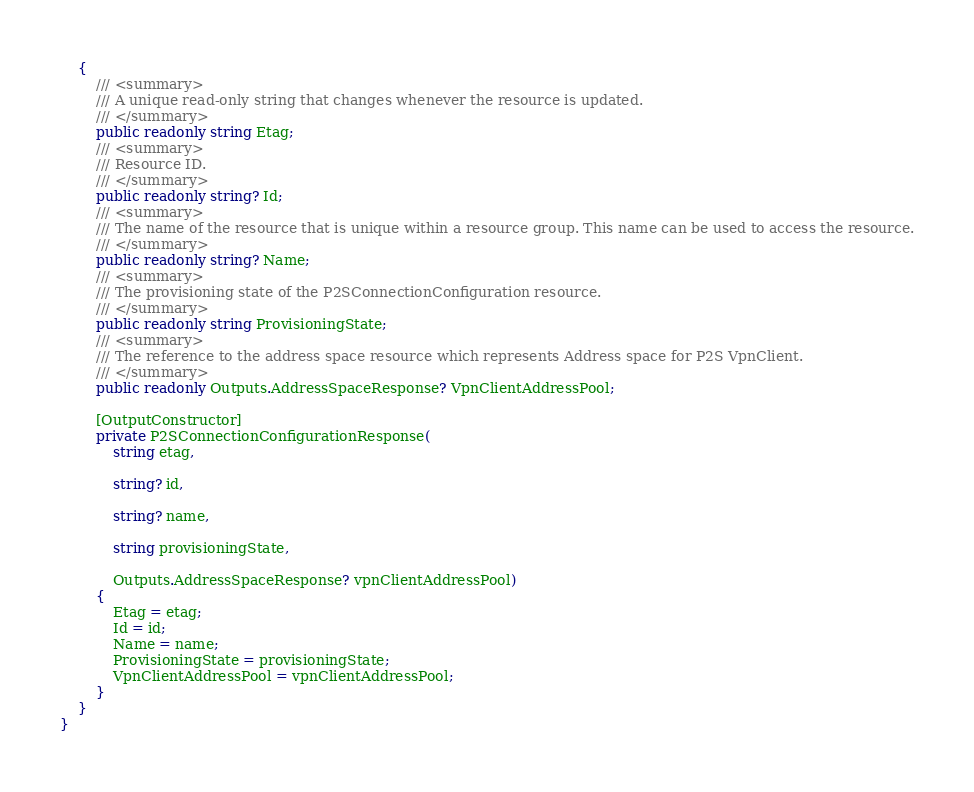Convert code to text. <code><loc_0><loc_0><loc_500><loc_500><_C#_>    {
        /// <summary>
        /// A unique read-only string that changes whenever the resource is updated.
        /// </summary>
        public readonly string Etag;
        /// <summary>
        /// Resource ID.
        /// </summary>
        public readonly string? Id;
        /// <summary>
        /// The name of the resource that is unique within a resource group. This name can be used to access the resource.
        /// </summary>
        public readonly string? Name;
        /// <summary>
        /// The provisioning state of the P2SConnectionConfiguration resource.
        /// </summary>
        public readonly string ProvisioningState;
        /// <summary>
        /// The reference to the address space resource which represents Address space for P2S VpnClient.
        /// </summary>
        public readonly Outputs.AddressSpaceResponse? VpnClientAddressPool;

        [OutputConstructor]
        private P2SConnectionConfigurationResponse(
            string etag,

            string? id,

            string? name,

            string provisioningState,

            Outputs.AddressSpaceResponse? vpnClientAddressPool)
        {
            Etag = etag;
            Id = id;
            Name = name;
            ProvisioningState = provisioningState;
            VpnClientAddressPool = vpnClientAddressPool;
        }
    }
}
</code> 